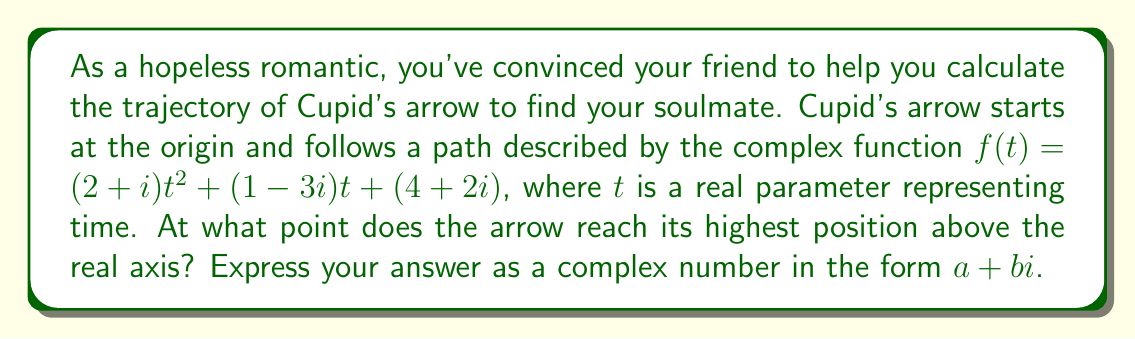Solve this math problem. Let's approach this step-by-step:

1) The function $f(t) = (2+i)t^2 + (1-3i)t + (4+2i)$ represents the position of the arrow at time $t$.

2) To find the highest point, we need to maximize the imaginary part of $f(t)$.

3) Let's separate the real and imaginary parts:
   $f(t) = (2t^2 + t + 4) + (t^2 - 3t + 2)i$

4) The imaginary part is $g(t) = t^2 - 3t + 2$

5) To find the maximum of $g(t)$, we differentiate and set it to zero:
   $g'(t) = 2t - 3$
   $2t - 3 = 0$
   $t = \frac{3}{2}$

6) The second derivative $g''(t) = 2 > 0$, confirming this is a maximum.

7) Now we need to find $f(\frac{3}{2})$:

   $f(\frac{3}{2}) = (2+i)(\frac{3}{2})^2 + (1-3i)(\frac{3}{2}) + (4+2i)$
   
   $= (2+i)(\frac{9}{4}) + (\frac{3}{2}-\frac{9}{2}i) + (4+2i)$
   
   $= (\frac{9}{2}+\frac{9}{4}i) + (\frac{3}{2}-\frac{9}{2}i) + (4+2i)$
   
   $= (\frac{9}{2}+\frac{3}{2}+4) + (\frac{9}{4}-\frac{9}{2}+2)i$
   
   $= 10 + (\frac{9}{4}-\frac{9}{2}+2)i$
   
   $= 10 + (\frac{9-18+8}{4})i$
   
   $= 10 - \frac{1}{4}i$
Answer: $10 - \frac{1}{4}i$ 